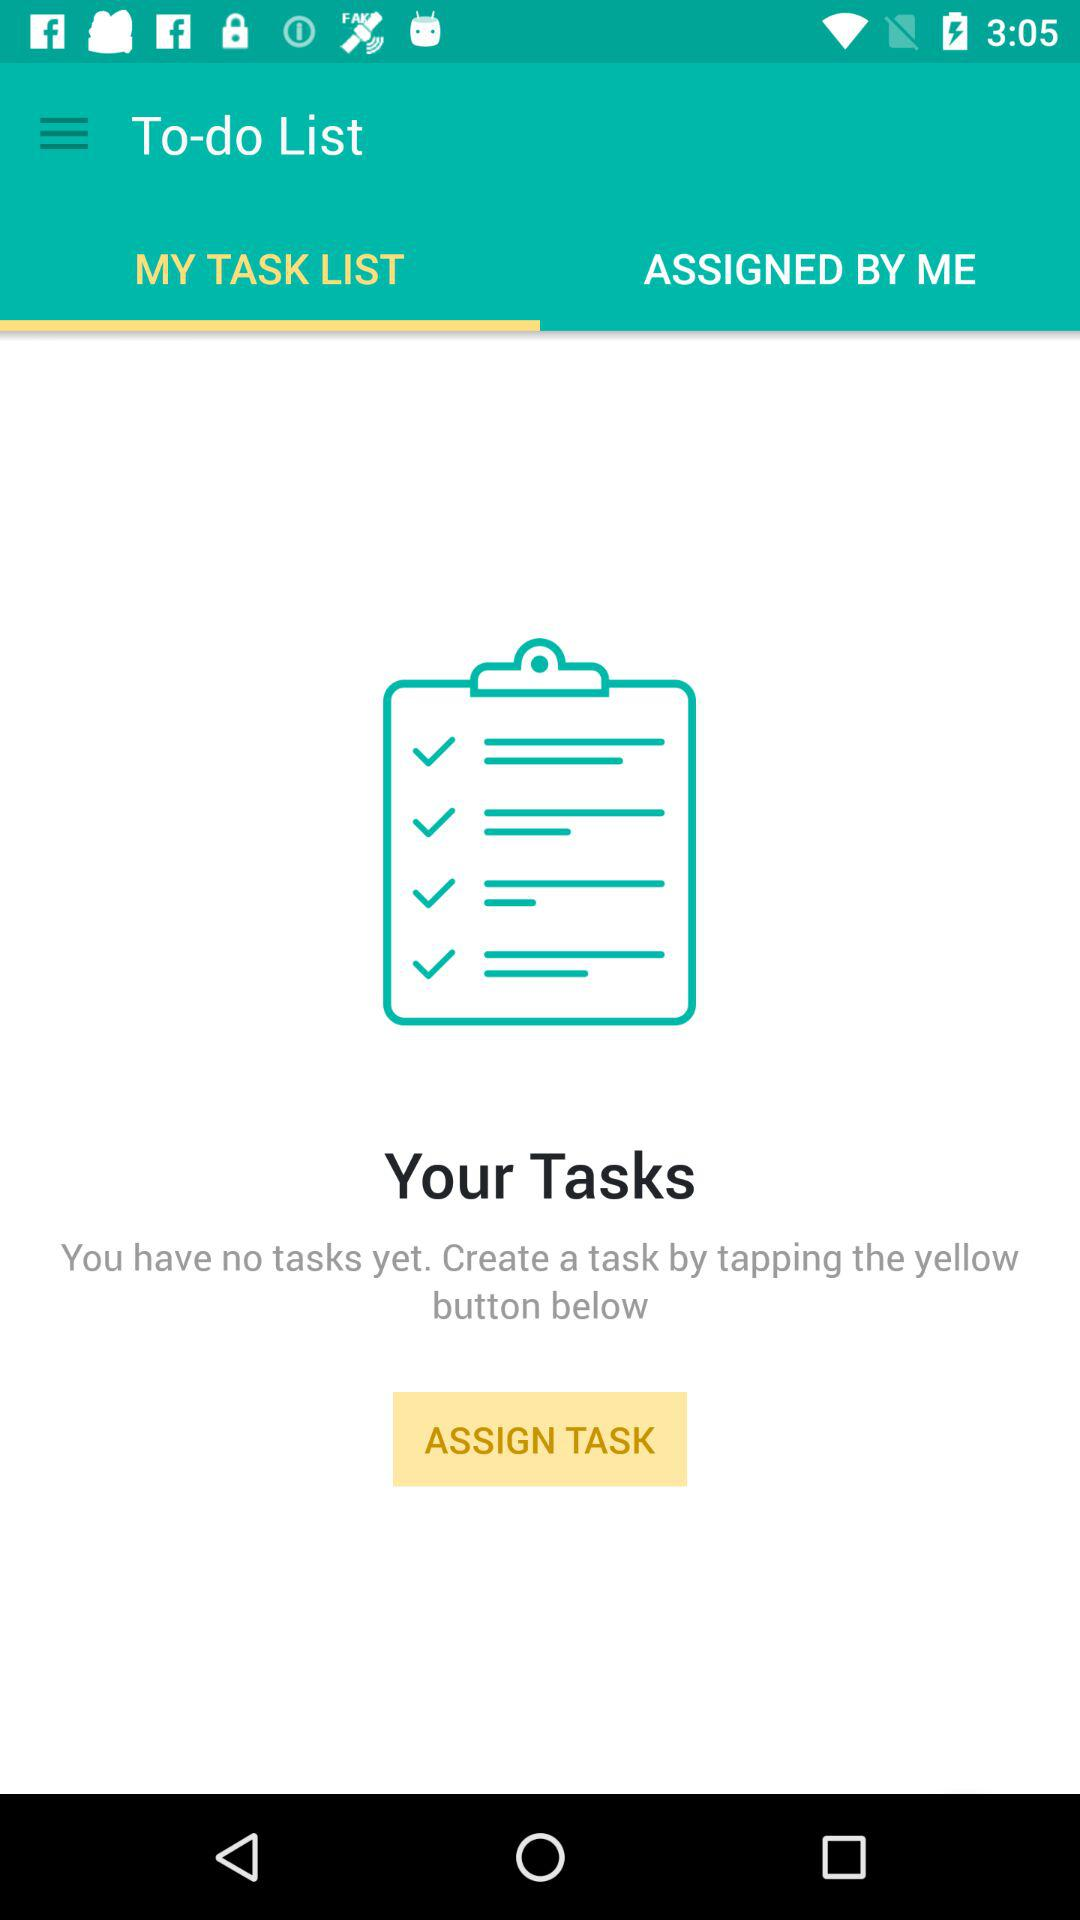How many tasks do I have?
Answer the question using a single word or phrase. 0 